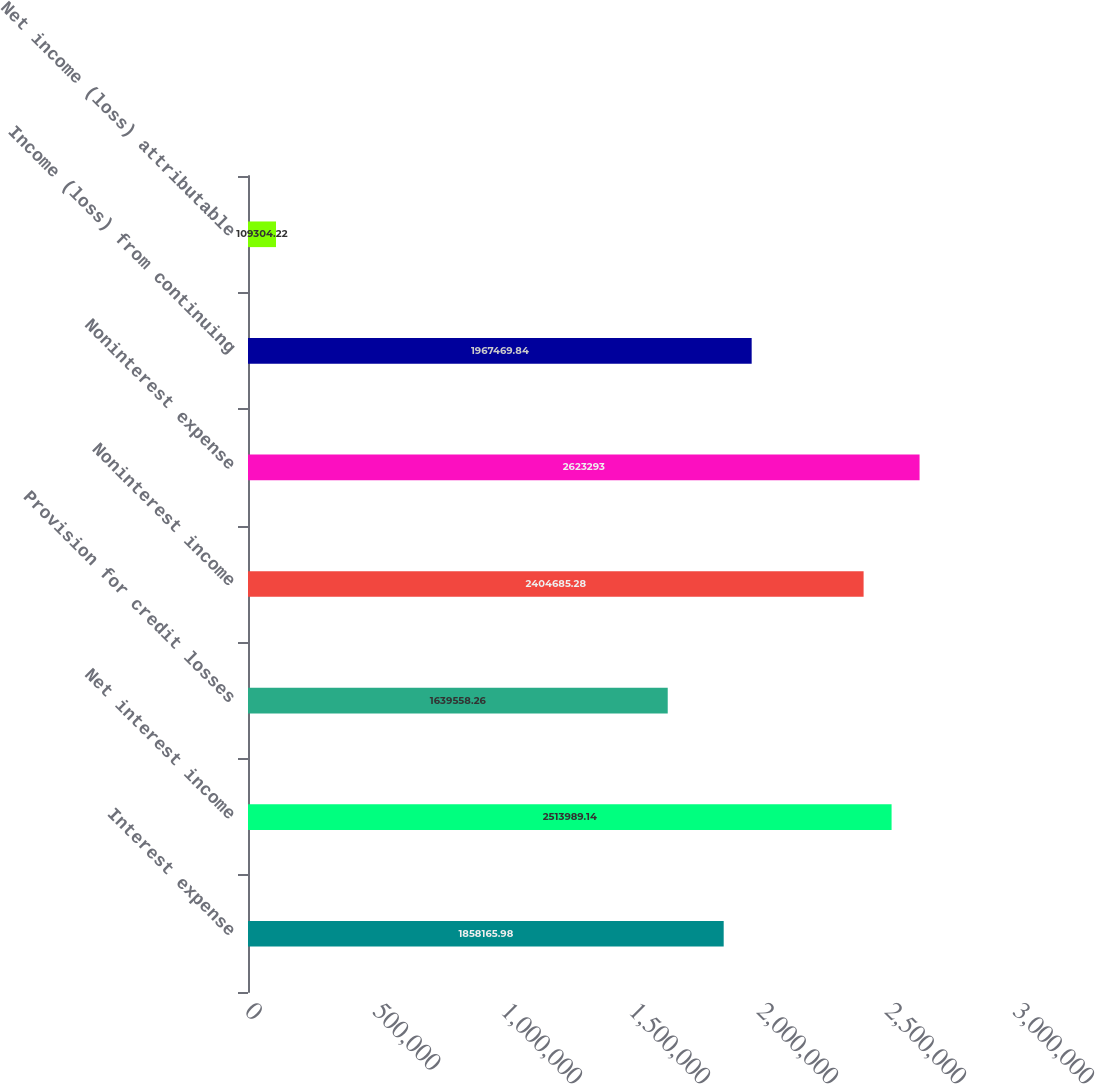Convert chart to OTSL. <chart><loc_0><loc_0><loc_500><loc_500><bar_chart><fcel>Interest expense<fcel>Net interest income<fcel>Provision for credit losses<fcel>Noninterest income<fcel>Noninterest expense<fcel>Income (loss) from continuing<fcel>Net income (loss) attributable<nl><fcel>1.85817e+06<fcel>2.51399e+06<fcel>1.63956e+06<fcel>2.40469e+06<fcel>2.62329e+06<fcel>1.96747e+06<fcel>109304<nl></chart> 